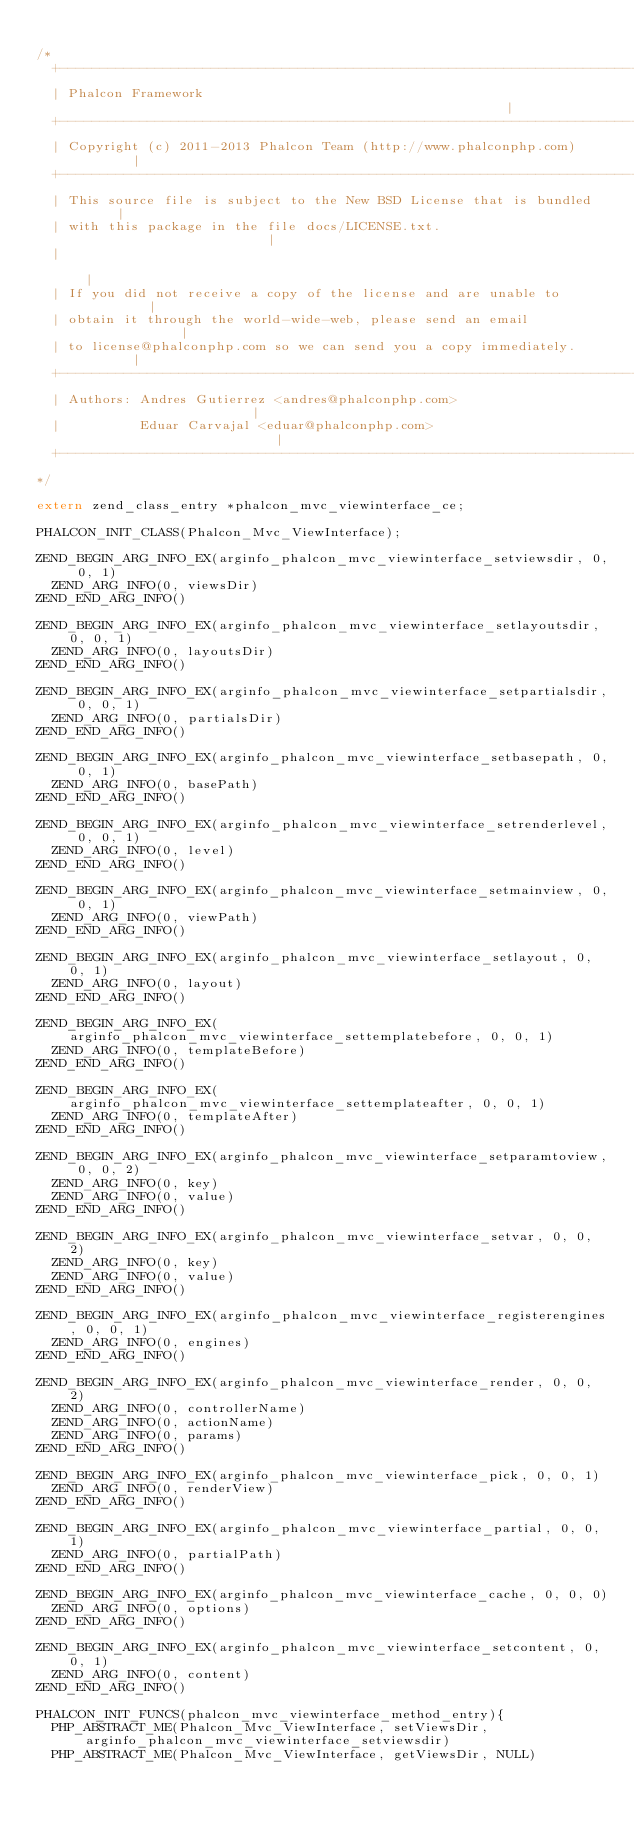Convert code to text. <code><loc_0><loc_0><loc_500><loc_500><_C_>
/*
  +------------------------------------------------------------------------+
  | Phalcon Framework                                                      |
  +------------------------------------------------------------------------+
  | Copyright (c) 2011-2013 Phalcon Team (http://www.phalconphp.com)       |
  +------------------------------------------------------------------------+
  | This source file is subject to the New BSD License that is bundled     |
  | with this package in the file docs/LICENSE.txt.                        |
  |                                                                        |
  | If you did not receive a copy of the license and are unable to         |
  | obtain it through the world-wide-web, please send an email             |
  | to license@phalconphp.com so we can send you a copy immediately.       |
  +------------------------------------------------------------------------+
  | Authors: Andres Gutierrez <andres@phalconphp.com>                      |
  |          Eduar Carvajal <eduar@phalconphp.com>                         |
  +------------------------------------------------------------------------+
*/

extern zend_class_entry *phalcon_mvc_viewinterface_ce;

PHALCON_INIT_CLASS(Phalcon_Mvc_ViewInterface);

ZEND_BEGIN_ARG_INFO_EX(arginfo_phalcon_mvc_viewinterface_setviewsdir, 0, 0, 1)
	ZEND_ARG_INFO(0, viewsDir)
ZEND_END_ARG_INFO()

ZEND_BEGIN_ARG_INFO_EX(arginfo_phalcon_mvc_viewinterface_setlayoutsdir, 0, 0, 1)
	ZEND_ARG_INFO(0, layoutsDir)
ZEND_END_ARG_INFO()

ZEND_BEGIN_ARG_INFO_EX(arginfo_phalcon_mvc_viewinterface_setpartialsdir, 0, 0, 1)
	ZEND_ARG_INFO(0, partialsDir)
ZEND_END_ARG_INFO()

ZEND_BEGIN_ARG_INFO_EX(arginfo_phalcon_mvc_viewinterface_setbasepath, 0, 0, 1)
	ZEND_ARG_INFO(0, basePath)
ZEND_END_ARG_INFO()

ZEND_BEGIN_ARG_INFO_EX(arginfo_phalcon_mvc_viewinterface_setrenderlevel, 0, 0, 1)
	ZEND_ARG_INFO(0, level)
ZEND_END_ARG_INFO()

ZEND_BEGIN_ARG_INFO_EX(arginfo_phalcon_mvc_viewinterface_setmainview, 0, 0, 1)
	ZEND_ARG_INFO(0, viewPath)
ZEND_END_ARG_INFO()

ZEND_BEGIN_ARG_INFO_EX(arginfo_phalcon_mvc_viewinterface_setlayout, 0, 0, 1)
	ZEND_ARG_INFO(0, layout)
ZEND_END_ARG_INFO()

ZEND_BEGIN_ARG_INFO_EX(arginfo_phalcon_mvc_viewinterface_settemplatebefore, 0, 0, 1)
	ZEND_ARG_INFO(0, templateBefore)
ZEND_END_ARG_INFO()

ZEND_BEGIN_ARG_INFO_EX(arginfo_phalcon_mvc_viewinterface_settemplateafter, 0, 0, 1)
	ZEND_ARG_INFO(0, templateAfter)
ZEND_END_ARG_INFO()

ZEND_BEGIN_ARG_INFO_EX(arginfo_phalcon_mvc_viewinterface_setparamtoview, 0, 0, 2)
	ZEND_ARG_INFO(0, key)
	ZEND_ARG_INFO(0, value)
ZEND_END_ARG_INFO()

ZEND_BEGIN_ARG_INFO_EX(arginfo_phalcon_mvc_viewinterface_setvar, 0, 0, 2)
	ZEND_ARG_INFO(0, key)
	ZEND_ARG_INFO(0, value)
ZEND_END_ARG_INFO()

ZEND_BEGIN_ARG_INFO_EX(arginfo_phalcon_mvc_viewinterface_registerengines, 0, 0, 1)
	ZEND_ARG_INFO(0, engines)
ZEND_END_ARG_INFO()

ZEND_BEGIN_ARG_INFO_EX(arginfo_phalcon_mvc_viewinterface_render, 0, 0, 2)
	ZEND_ARG_INFO(0, controllerName)
	ZEND_ARG_INFO(0, actionName)
	ZEND_ARG_INFO(0, params)
ZEND_END_ARG_INFO()

ZEND_BEGIN_ARG_INFO_EX(arginfo_phalcon_mvc_viewinterface_pick, 0, 0, 1)
	ZEND_ARG_INFO(0, renderView)
ZEND_END_ARG_INFO()

ZEND_BEGIN_ARG_INFO_EX(arginfo_phalcon_mvc_viewinterface_partial, 0, 0, 1)
	ZEND_ARG_INFO(0, partialPath)
ZEND_END_ARG_INFO()

ZEND_BEGIN_ARG_INFO_EX(arginfo_phalcon_mvc_viewinterface_cache, 0, 0, 0)
	ZEND_ARG_INFO(0, options)
ZEND_END_ARG_INFO()

ZEND_BEGIN_ARG_INFO_EX(arginfo_phalcon_mvc_viewinterface_setcontent, 0, 0, 1)
	ZEND_ARG_INFO(0, content)
ZEND_END_ARG_INFO()

PHALCON_INIT_FUNCS(phalcon_mvc_viewinterface_method_entry){
	PHP_ABSTRACT_ME(Phalcon_Mvc_ViewInterface, setViewsDir, arginfo_phalcon_mvc_viewinterface_setviewsdir)
	PHP_ABSTRACT_ME(Phalcon_Mvc_ViewInterface, getViewsDir, NULL)</code> 